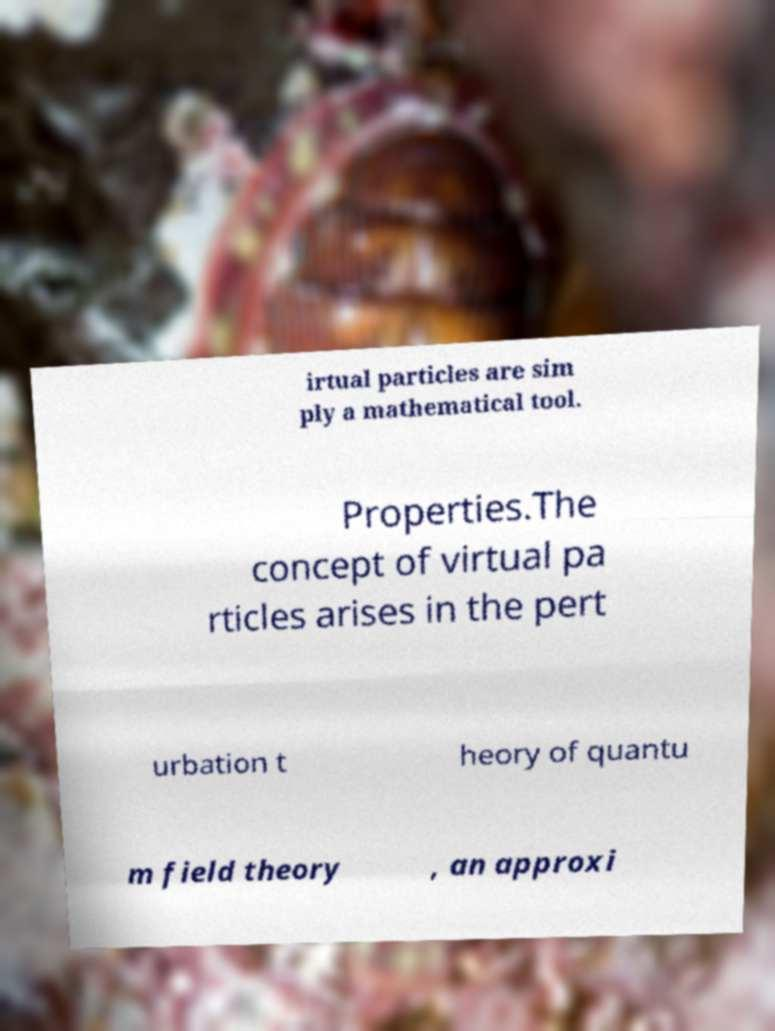I need the written content from this picture converted into text. Can you do that? irtual particles are sim ply a mathematical tool. Properties.The concept of virtual pa rticles arises in the pert urbation t heory of quantu m field theory , an approxi 